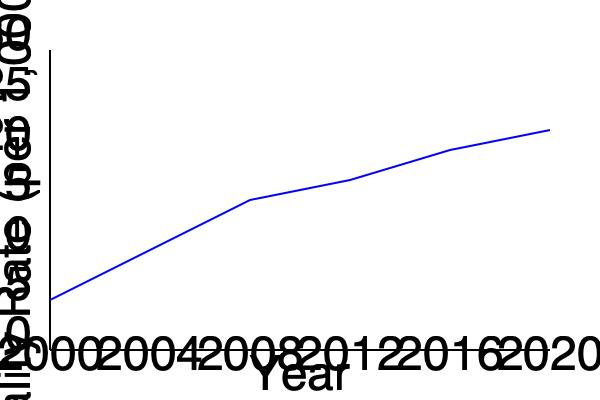Based on the trend shown in the graph, what is the estimated percentage decrease in infant mortality rate in Ukraine from 2000 to 2020? To calculate the percentage decrease in infant mortality rate from 2000 to 2020:

1. Identify the approximate infant mortality rates:
   - 2000: 15 per 1,000 live births
   - 2020: 7 per 1,000 live births

2. Calculate the absolute decrease:
   $15 - 7 = 8$ per 1,000 live births

3. Calculate the percentage decrease:
   Percentage decrease = $\frac{\text{Decrease}}{\text{Original Value}} \times 100\%$
   
   $= \frac{8}{15} \times 100\% = 0.5333... \times 100\% \approx 53.33\%$

4. Round to the nearest whole number:
   53.33% rounds to 53%

Therefore, the estimated percentage decrease in infant mortality rate in Ukraine from 2000 to 2020 is approximately 53%.
Answer: 53% 